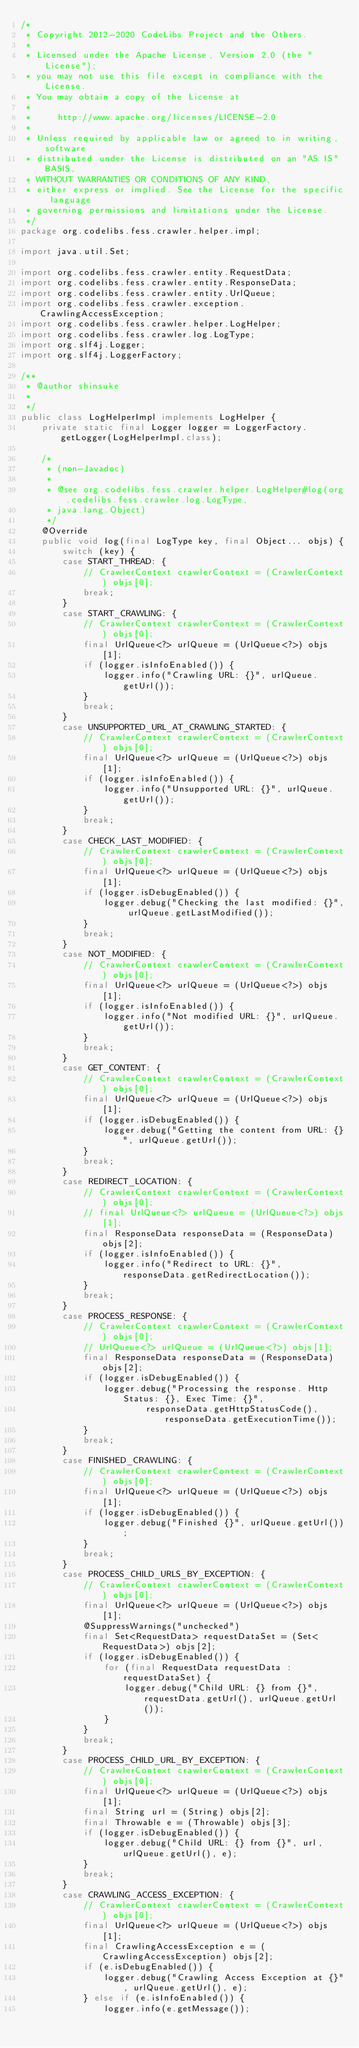<code> <loc_0><loc_0><loc_500><loc_500><_Java_>/*
 * Copyright 2012-2020 CodeLibs Project and the Others.
 *
 * Licensed under the Apache License, Version 2.0 (the "License");
 * you may not use this file except in compliance with the License.
 * You may obtain a copy of the License at
 *
 *     http://www.apache.org/licenses/LICENSE-2.0
 *
 * Unless required by applicable law or agreed to in writing, software
 * distributed under the License is distributed on an "AS IS" BASIS,
 * WITHOUT WARRANTIES OR CONDITIONS OF ANY KIND,
 * either express or implied. See the License for the specific language
 * governing permissions and limitations under the License.
 */
package org.codelibs.fess.crawler.helper.impl;

import java.util.Set;

import org.codelibs.fess.crawler.entity.RequestData;
import org.codelibs.fess.crawler.entity.ResponseData;
import org.codelibs.fess.crawler.entity.UrlQueue;
import org.codelibs.fess.crawler.exception.CrawlingAccessException;
import org.codelibs.fess.crawler.helper.LogHelper;
import org.codelibs.fess.crawler.log.LogType;
import org.slf4j.Logger;
import org.slf4j.LoggerFactory;

/**
 * @author shinsuke
 *
 */
public class LogHelperImpl implements LogHelper {
    private static final Logger logger = LoggerFactory.getLogger(LogHelperImpl.class);

    /*
     * (non-Javadoc)
     *
     * @see org.codelibs.fess.crawler.helper.LogHelper#log(org.codelibs.fess.crawler.log.LogType,
     * java.lang.Object)
     */
    @Override
    public void log(final LogType key, final Object... objs) {
        switch (key) {
        case START_THREAD: {
            // CrawlerContext crawlerContext = (CrawlerContext) objs[0];
            break;
        }
        case START_CRAWLING: {
            // CrawlerContext crawlerContext = (CrawlerContext) objs[0];
            final UrlQueue<?> urlQueue = (UrlQueue<?>) objs[1];
            if (logger.isInfoEnabled()) {
                logger.info("Crawling URL: {}", urlQueue.getUrl());
            }
            break;
        }
        case UNSUPPORTED_URL_AT_CRAWLING_STARTED: {
            // CrawlerContext crawlerContext = (CrawlerContext) objs[0];
            final UrlQueue<?> urlQueue = (UrlQueue<?>) objs[1];
            if (logger.isInfoEnabled()) {
                logger.info("Unsupported URL: {}", urlQueue.getUrl());
            }
            break;
        }
        case CHECK_LAST_MODIFIED: {
            // CrawlerContext crawlerContext = (CrawlerContext) objs[0];
            final UrlQueue<?> urlQueue = (UrlQueue<?>) objs[1];
            if (logger.isDebugEnabled()) {
                logger.debug("Checking the last modified: {}", urlQueue.getLastModified());
            }
            break;
        }
        case NOT_MODIFIED: {
            // CrawlerContext crawlerContext = (CrawlerContext) objs[0];
            final UrlQueue<?> urlQueue = (UrlQueue<?>) objs[1];
            if (logger.isInfoEnabled()) {
                logger.info("Not modified URL: {}", urlQueue.getUrl());
            }
            break;
        }
        case GET_CONTENT: {
            // CrawlerContext crawlerContext = (CrawlerContext) objs[0];
            final UrlQueue<?> urlQueue = (UrlQueue<?>) objs[1];
            if (logger.isDebugEnabled()) {
                logger.debug("Getting the content from URL: {}", urlQueue.getUrl());
            }
            break;
        }
        case REDIRECT_LOCATION: {
            // CrawlerContext crawlerContext = (CrawlerContext) objs[0];
            // final UrlQueue<?> urlQueue = (UrlQueue<?>) objs[1];
            final ResponseData responseData = (ResponseData) objs[2];
            if (logger.isInfoEnabled()) {
                logger.info("Redirect to URL: {}", responseData.getRedirectLocation());
            }
            break;
        }
        case PROCESS_RESPONSE: {
            // CrawlerContext crawlerContext = (CrawlerContext) objs[0];
            // UrlQueue<?> urlQueue = (UrlQueue<?>) objs[1];
            final ResponseData responseData = (ResponseData) objs[2];
            if (logger.isDebugEnabled()) {
                logger.debug("Processing the response. Http Status: {}, Exec Time: {}",
                        responseData.getHttpStatusCode(), responseData.getExecutionTime());
            }
            break;
        }
        case FINISHED_CRAWLING: {
            // CrawlerContext crawlerContext = (CrawlerContext) objs[0];
            final UrlQueue<?> urlQueue = (UrlQueue<?>) objs[1];
            if (logger.isDebugEnabled()) {
                logger.debug("Finished {}", urlQueue.getUrl());
            }
            break;
        }
        case PROCESS_CHILD_URLS_BY_EXCEPTION: {
            // CrawlerContext crawlerContext = (CrawlerContext) objs[0];
            final UrlQueue<?> urlQueue = (UrlQueue<?>) objs[1];
            @SuppressWarnings("unchecked")
            final Set<RequestData> requestDataSet = (Set<RequestData>) objs[2];
            if (logger.isDebugEnabled()) {
                for (final RequestData requestData : requestDataSet) {
                    logger.debug("Child URL: {} from {}", requestData.getUrl(), urlQueue.getUrl());
                }
            }
            break;
        }
        case PROCESS_CHILD_URL_BY_EXCEPTION: {
            // CrawlerContext crawlerContext = (CrawlerContext) objs[0];
            final UrlQueue<?> urlQueue = (UrlQueue<?>) objs[1];
            final String url = (String) objs[2];
            final Throwable e = (Throwable) objs[3];
            if (logger.isDebugEnabled()) {
                logger.debug("Child URL: {} from {}", url, urlQueue.getUrl(), e);
            }
            break;
        }
        case CRAWLING_ACCESS_EXCEPTION: {
            // CrawlerContext crawlerContext = (CrawlerContext) objs[0];
            final UrlQueue<?> urlQueue = (UrlQueue<?>) objs[1];
            final CrawlingAccessException e = (CrawlingAccessException) objs[2];
            if (e.isDebugEnabled()) {
                logger.debug("Crawling Access Exception at {}", urlQueue.getUrl(), e);
            } else if (e.isInfoEnabled()) {
                logger.info(e.getMessage());</code> 